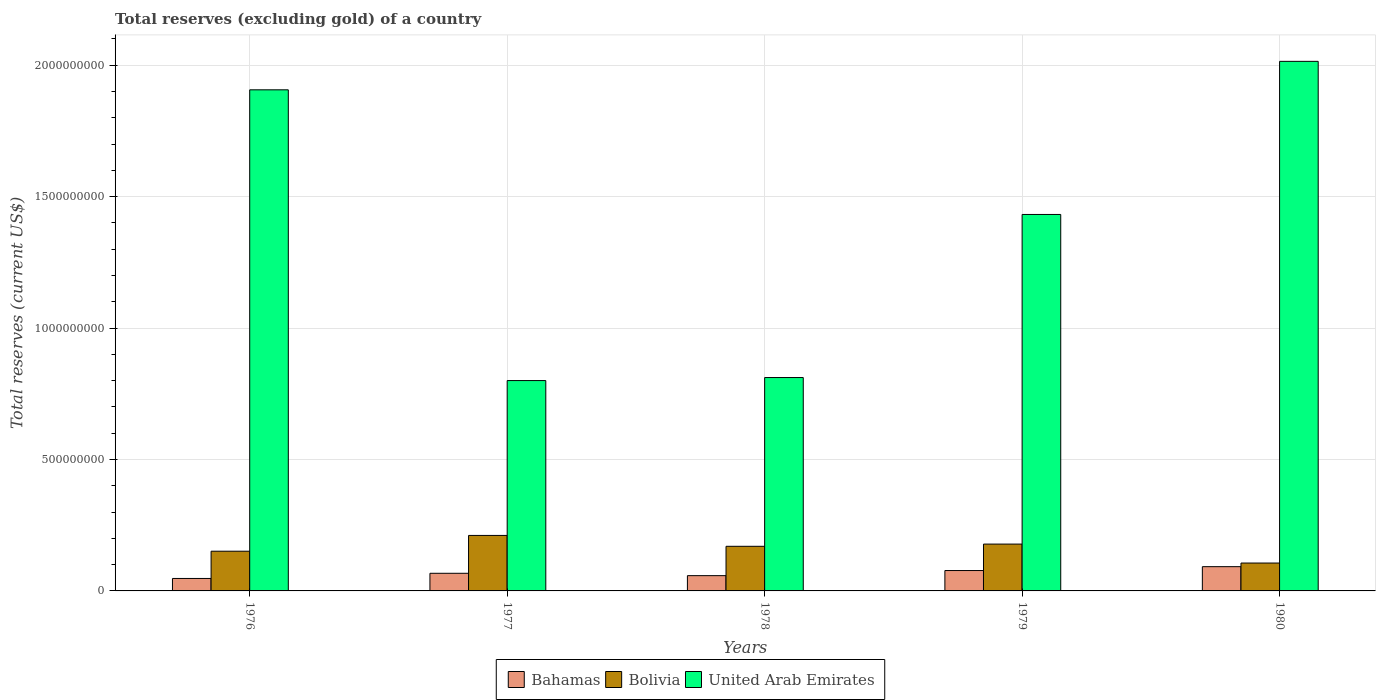How many different coloured bars are there?
Provide a succinct answer. 3. How many bars are there on the 4th tick from the left?
Your answer should be compact. 3. What is the label of the 4th group of bars from the left?
Offer a terse response. 1979. What is the total reserves (excluding gold) in United Arab Emirates in 1978?
Provide a succinct answer. 8.12e+08. Across all years, what is the maximum total reserves (excluding gold) in Bolivia?
Offer a very short reply. 2.11e+08. Across all years, what is the minimum total reserves (excluding gold) in United Arab Emirates?
Ensure brevity in your answer.  8.00e+08. In which year was the total reserves (excluding gold) in Bahamas minimum?
Provide a short and direct response. 1976. What is the total total reserves (excluding gold) in Bolivia in the graph?
Your response must be concise. 8.16e+08. What is the difference between the total reserves (excluding gold) in Bahamas in 1976 and that in 1977?
Give a very brief answer. -1.97e+07. What is the difference between the total reserves (excluding gold) in Bahamas in 1977 and the total reserves (excluding gold) in United Arab Emirates in 1980?
Your answer should be very brief. -1.95e+09. What is the average total reserves (excluding gold) in Bahamas per year?
Offer a terse response. 6.85e+07. In the year 1977, what is the difference between the total reserves (excluding gold) in United Arab Emirates and total reserves (excluding gold) in Bahamas?
Ensure brevity in your answer.  7.33e+08. In how many years, is the total reserves (excluding gold) in Bahamas greater than 400000000 US$?
Make the answer very short. 0. What is the ratio of the total reserves (excluding gold) in Bahamas in 1976 to that in 1978?
Give a very brief answer. 0.82. Is the total reserves (excluding gold) in Bolivia in 1976 less than that in 1980?
Give a very brief answer. No. Is the difference between the total reserves (excluding gold) in United Arab Emirates in 1976 and 1979 greater than the difference between the total reserves (excluding gold) in Bahamas in 1976 and 1979?
Your answer should be compact. Yes. What is the difference between the highest and the second highest total reserves (excluding gold) in United Arab Emirates?
Keep it short and to the point. 1.08e+08. What is the difference between the highest and the lowest total reserves (excluding gold) in Bahamas?
Your answer should be very brief. 4.49e+07. In how many years, is the total reserves (excluding gold) in Bahamas greater than the average total reserves (excluding gold) in Bahamas taken over all years?
Keep it short and to the point. 2. What does the 2nd bar from the left in 1977 represents?
Offer a very short reply. Bolivia. How many years are there in the graph?
Your answer should be compact. 5. What is the difference between two consecutive major ticks on the Y-axis?
Offer a very short reply. 5.00e+08. Are the values on the major ticks of Y-axis written in scientific E-notation?
Make the answer very short. No. Does the graph contain grids?
Provide a short and direct response. Yes. What is the title of the graph?
Provide a succinct answer. Total reserves (excluding gold) of a country. Does "Bahamas" appear as one of the legend labels in the graph?
Provide a succinct answer. Yes. What is the label or title of the X-axis?
Make the answer very short. Years. What is the label or title of the Y-axis?
Offer a terse response. Total reserves (current US$). What is the Total reserves (current US$) in Bahamas in 1976?
Ensure brevity in your answer.  4.74e+07. What is the Total reserves (current US$) in Bolivia in 1976?
Provide a succinct answer. 1.51e+08. What is the Total reserves (current US$) in United Arab Emirates in 1976?
Your answer should be compact. 1.91e+09. What is the Total reserves (current US$) of Bahamas in 1977?
Offer a terse response. 6.71e+07. What is the Total reserves (current US$) in Bolivia in 1977?
Your response must be concise. 2.11e+08. What is the Total reserves (current US$) in United Arab Emirates in 1977?
Your answer should be very brief. 8.00e+08. What is the Total reserves (current US$) of Bahamas in 1978?
Give a very brief answer. 5.81e+07. What is the Total reserves (current US$) in Bolivia in 1978?
Give a very brief answer. 1.70e+08. What is the Total reserves (current US$) of United Arab Emirates in 1978?
Provide a short and direct response. 8.12e+08. What is the Total reserves (current US$) in Bahamas in 1979?
Make the answer very short. 7.75e+07. What is the Total reserves (current US$) in Bolivia in 1979?
Your response must be concise. 1.78e+08. What is the Total reserves (current US$) of United Arab Emirates in 1979?
Your response must be concise. 1.43e+09. What is the Total reserves (current US$) in Bahamas in 1980?
Your answer should be very brief. 9.23e+07. What is the Total reserves (current US$) in Bolivia in 1980?
Your answer should be very brief. 1.06e+08. What is the Total reserves (current US$) of United Arab Emirates in 1980?
Your response must be concise. 2.01e+09. Across all years, what is the maximum Total reserves (current US$) in Bahamas?
Ensure brevity in your answer.  9.23e+07. Across all years, what is the maximum Total reserves (current US$) of Bolivia?
Your answer should be very brief. 2.11e+08. Across all years, what is the maximum Total reserves (current US$) in United Arab Emirates?
Offer a terse response. 2.01e+09. Across all years, what is the minimum Total reserves (current US$) of Bahamas?
Your answer should be compact. 4.74e+07. Across all years, what is the minimum Total reserves (current US$) in Bolivia?
Your response must be concise. 1.06e+08. Across all years, what is the minimum Total reserves (current US$) in United Arab Emirates?
Provide a succinct answer. 8.00e+08. What is the total Total reserves (current US$) in Bahamas in the graph?
Provide a succinct answer. 3.42e+08. What is the total Total reserves (current US$) in Bolivia in the graph?
Offer a terse response. 8.16e+08. What is the total Total reserves (current US$) of United Arab Emirates in the graph?
Your answer should be very brief. 6.97e+09. What is the difference between the Total reserves (current US$) in Bahamas in 1976 and that in 1977?
Your answer should be very brief. -1.97e+07. What is the difference between the Total reserves (current US$) of Bolivia in 1976 and that in 1977?
Your response must be concise. -6.00e+07. What is the difference between the Total reserves (current US$) in United Arab Emirates in 1976 and that in 1977?
Keep it short and to the point. 1.11e+09. What is the difference between the Total reserves (current US$) in Bahamas in 1976 and that in 1978?
Ensure brevity in your answer.  -1.07e+07. What is the difference between the Total reserves (current US$) in Bolivia in 1976 and that in 1978?
Give a very brief answer. -1.87e+07. What is the difference between the Total reserves (current US$) in United Arab Emirates in 1976 and that in 1978?
Make the answer very short. 1.09e+09. What is the difference between the Total reserves (current US$) in Bahamas in 1976 and that in 1979?
Provide a short and direct response. -3.01e+07. What is the difference between the Total reserves (current US$) of Bolivia in 1976 and that in 1979?
Your response must be concise. -2.71e+07. What is the difference between the Total reserves (current US$) of United Arab Emirates in 1976 and that in 1979?
Your answer should be compact. 4.74e+08. What is the difference between the Total reserves (current US$) of Bahamas in 1976 and that in 1980?
Make the answer very short. -4.49e+07. What is the difference between the Total reserves (current US$) of Bolivia in 1976 and that in 1980?
Provide a short and direct response. 4.50e+07. What is the difference between the Total reserves (current US$) in United Arab Emirates in 1976 and that in 1980?
Your answer should be very brief. -1.08e+08. What is the difference between the Total reserves (current US$) of Bahamas in 1977 and that in 1978?
Give a very brief answer. 8.97e+06. What is the difference between the Total reserves (current US$) of Bolivia in 1977 and that in 1978?
Ensure brevity in your answer.  4.13e+07. What is the difference between the Total reserves (current US$) in United Arab Emirates in 1977 and that in 1978?
Your answer should be compact. -1.16e+07. What is the difference between the Total reserves (current US$) in Bahamas in 1977 and that in 1979?
Offer a very short reply. -1.05e+07. What is the difference between the Total reserves (current US$) of Bolivia in 1977 and that in 1979?
Offer a very short reply. 3.29e+07. What is the difference between the Total reserves (current US$) of United Arab Emirates in 1977 and that in 1979?
Offer a terse response. -6.32e+08. What is the difference between the Total reserves (current US$) in Bahamas in 1977 and that in 1980?
Your answer should be compact. -2.52e+07. What is the difference between the Total reserves (current US$) of Bolivia in 1977 and that in 1980?
Ensure brevity in your answer.  1.05e+08. What is the difference between the Total reserves (current US$) in United Arab Emirates in 1977 and that in 1980?
Provide a succinct answer. -1.21e+09. What is the difference between the Total reserves (current US$) in Bahamas in 1978 and that in 1979?
Give a very brief answer. -1.94e+07. What is the difference between the Total reserves (current US$) in Bolivia in 1978 and that in 1979?
Make the answer very short. -8.43e+06. What is the difference between the Total reserves (current US$) in United Arab Emirates in 1978 and that in 1979?
Your response must be concise. -6.20e+08. What is the difference between the Total reserves (current US$) of Bahamas in 1978 and that in 1980?
Your answer should be compact. -3.42e+07. What is the difference between the Total reserves (current US$) in Bolivia in 1978 and that in 1980?
Offer a terse response. 6.37e+07. What is the difference between the Total reserves (current US$) of United Arab Emirates in 1978 and that in 1980?
Make the answer very short. -1.20e+09. What is the difference between the Total reserves (current US$) of Bahamas in 1979 and that in 1980?
Keep it short and to the point. -1.47e+07. What is the difference between the Total reserves (current US$) in Bolivia in 1979 and that in 1980?
Keep it short and to the point. 7.21e+07. What is the difference between the Total reserves (current US$) of United Arab Emirates in 1979 and that in 1980?
Make the answer very short. -5.82e+08. What is the difference between the Total reserves (current US$) of Bahamas in 1976 and the Total reserves (current US$) of Bolivia in 1977?
Offer a very short reply. -1.64e+08. What is the difference between the Total reserves (current US$) in Bahamas in 1976 and the Total reserves (current US$) in United Arab Emirates in 1977?
Provide a succinct answer. -7.53e+08. What is the difference between the Total reserves (current US$) in Bolivia in 1976 and the Total reserves (current US$) in United Arab Emirates in 1977?
Your answer should be compact. -6.49e+08. What is the difference between the Total reserves (current US$) of Bahamas in 1976 and the Total reserves (current US$) of Bolivia in 1978?
Ensure brevity in your answer.  -1.22e+08. What is the difference between the Total reserves (current US$) in Bahamas in 1976 and the Total reserves (current US$) in United Arab Emirates in 1978?
Provide a short and direct response. -7.64e+08. What is the difference between the Total reserves (current US$) in Bolivia in 1976 and the Total reserves (current US$) in United Arab Emirates in 1978?
Provide a succinct answer. -6.61e+08. What is the difference between the Total reserves (current US$) in Bahamas in 1976 and the Total reserves (current US$) in Bolivia in 1979?
Provide a succinct answer. -1.31e+08. What is the difference between the Total reserves (current US$) of Bahamas in 1976 and the Total reserves (current US$) of United Arab Emirates in 1979?
Ensure brevity in your answer.  -1.38e+09. What is the difference between the Total reserves (current US$) of Bolivia in 1976 and the Total reserves (current US$) of United Arab Emirates in 1979?
Keep it short and to the point. -1.28e+09. What is the difference between the Total reserves (current US$) in Bahamas in 1976 and the Total reserves (current US$) in Bolivia in 1980?
Your response must be concise. -5.87e+07. What is the difference between the Total reserves (current US$) of Bahamas in 1976 and the Total reserves (current US$) of United Arab Emirates in 1980?
Ensure brevity in your answer.  -1.97e+09. What is the difference between the Total reserves (current US$) of Bolivia in 1976 and the Total reserves (current US$) of United Arab Emirates in 1980?
Your response must be concise. -1.86e+09. What is the difference between the Total reserves (current US$) in Bahamas in 1977 and the Total reserves (current US$) in Bolivia in 1978?
Give a very brief answer. -1.03e+08. What is the difference between the Total reserves (current US$) of Bahamas in 1977 and the Total reserves (current US$) of United Arab Emirates in 1978?
Provide a succinct answer. -7.45e+08. What is the difference between the Total reserves (current US$) in Bolivia in 1977 and the Total reserves (current US$) in United Arab Emirates in 1978?
Your answer should be very brief. -6.01e+08. What is the difference between the Total reserves (current US$) in Bahamas in 1977 and the Total reserves (current US$) in Bolivia in 1979?
Offer a very short reply. -1.11e+08. What is the difference between the Total reserves (current US$) in Bahamas in 1977 and the Total reserves (current US$) in United Arab Emirates in 1979?
Give a very brief answer. -1.37e+09. What is the difference between the Total reserves (current US$) in Bolivia in 1977 and the Total reserves (current US$) in United Arab Emirates in 1979?
Give a very brief answer. -1.22e+09. What is the difference between the Total reserves (current US$) of Bahamas in 1977 and the Total reserves (current US$) of Bolivia in 1980?
Provide a succinct answer. -3.90e+07. What is the difference between the Total reserves (current US$) in Bahamas in 1977 and the Total reserves (current US$) in United Arab Emirates in 1980?
Offer a terse response. -1.95e+09. What is the difference between the Total reserves (current US$) in Bolivia in 1977 and the Total reserves (current US$) in United Arab Emirates in 1980?
Keep it short and to the point. -1.80e+09. What is the difference between the Total reserves (current US$) of Bahamas in 1978 and the Total reserves (current US$) of Bolivia in 1979?
Your response must be concise. -1.20e+08. What is the difference between the Total reserves (current US$) of Bahamas in 1978 and the Total reserves (current US$) of United Arab Emirates in 1979?
Your response must be concise. -1.37e+09. What is the difference between the Total reserves (current US$) in Bolivia in 1978 and the Total reserves (current US$) in United Arab Emirates in 1979?
Ensure brevity in your answer.  -1.26e+09. What is the difference between the Total reserves (current US$) in Bahamas in 1978 and the Total reserves (current US$) in Bolivia in 1980?
Your answer should be compact. -4.80e+07. What is the difference between the Total reserves (current US$) of Bahamas in 1978 and the Total reserves (current US$) of United Arab Emirates in 1980?
Ensure brevity in your answer.  -1.96e+09. What is the difference between the Total reserves (current US$) of Bolivia in 1978 and the Total reserves (current US$) of United Arab Emirates in 1980?
Make the answer very short. -1.84e+09. What is the difference between the Total reserves (current US$) of Bahamas in 1979 and the Total reserves (current US$) of Bolivia in 1980?
Make the answer very short. -2.86e+07. What is the difference between the Total reserves (current US$) of Bahamas in 1979 and the Total reserves (current US$) of United Arab Emirates in 1980?
Make the answer very short. -1.94e+09. What is the difference between the Total reserves (current US$) of Bolivia in 1979 and the Total reserves (current US$) of United Arab Emirates in 1980?
Give a very brief answer. -1.84e+09. What is the average Total reserves (current US$) in Bahamas per year?
Offer a terse response. 6.85e+07. What is the average Total reserves (current US$) of Bolivia per year?
Offer a very short reply. 1.63e+08. What is the average Total reserves (current US$) of United Arab Emirates per year?
Your answer should be compact. 1.39e+09. In the year 1976, what is the difference between the Total reserves (current US$) in Bahamas and Total reserves (current US$) in Bolivia?
Ensure brevity in your answer.  -1.04e+08. In the year 1976, what is the difference between the Total reserves (current US$) in Bahamas and Total reserves (current US$) in United Arab Emirates?
Provide a short and direct response. -1.86e+09. In the year 1976, what is the difference between the Total reserves (current US$) in Bolivia and Total reserves (current US$) in United Arab Emirates?
Offer a terse response. -1.76e+09. In the year 1977, what is the difference between the Total reserves (current US$) in Bahamas and Total reserves (current US$) in Bolivia?
Your answer should be very brief. -1.44e+08. In the year 1977, what is the difference between the Total reserves (current US$) in Bahamas and Total reserves (current US$) in United Arab Emirates?
Provide a succinct answer. -7.33e+08. In the year 1977, what is the difference between the Total reserves (current US$) in Bolivia and Total reserves (current US$) in United Arab Emirates?
Keep it short and to the point. -5.89e+08. In the year 1978, what is the difference between the Total reserves (current US$) in Bahamas and Total reserves (current US$) in Bolivia?
Ensure brevity in your answer.  -1.12e+08. In the year 1978, what is the difference between the Total reserves (current US$) in Bahamas and Total reserves (current US$) in United Arab Emirates?
Offer a very short reply. -7.54e+08. In the year 1978, what is the difference between the Total reserves (current US$) of Bolivia and Total reserves (current US$) of United Arab Emirates?
Your response must be concise. -6.42e+08. In the year 1979, what is the difference between the Total reserves (current US$) of Bahamas and Total reserves (current US$) of Bolivia?
Provide a succinct answer. -1.01e+08. In the year 1979, what is the difference between the Total reserves (current US$) of Bahamas and Total reserves (current US$) of United Arab Emirates?
Your answer should be compact. -1.35e+09. In the year 1979, what is the difference between the Total reserves (current US$) of Bolivia and Total reserves (current US$) of United Arab Emirates?
Offer a terse response. -1.25e+09. In the year 1980, what is the difference between the Total reserves (current US$) in Bahamas and Total reserves (current US$) in Bolivia?
Offer a very short reply. -1.38e+07. In the year 1980, what is the difference between the Total reserves (current US$) in Bahamas and Total reserves (current US$) in United Arab Emirates?
Offer a terse response. -1.92e+09. In the year 1980, what is the difference between the Total reserves (current US$) in Bolivia and Total reserves (current US$) in United Arab Emirates?
Your response must be concise. -1.91e+09. What is the ratio of the Total reserves (current US$) in Bahamas in 1976 to that in 1977?
Provide a short and direct response. 0.71. What is the ratio of the Total reserves (current US$) of Bolivia in 1976 to that in 1977?
Provide a succinct answer. 0.72. What is the ratio of the Total reserves (current US$) of United Arab Emirates in 1976 to that in 1977?
Keep it short and to the point. 2.38. What is the ratio of the Total reserves (current US$) of Bahamas in 1976 to that in 1978?
Offer a terse response. 0.82. What is the ratio of the Total reserves (current US$) in Bolivia in 1976 to that in 1978?
Your answer should be very brief. 0.89. What is the ratio of the Total reserves (current US$) of United Arab Emirates in 1976 to that in 1978?
Give a very brief answer. 2.35. What is the ratio of the Total reserves (current US$) of Bahamas in 1976 to that in 1979?
Make the answer very short. 0.61. What is the ratio of the Total reserves (current US$) in Bolivia in 1976 to that in 1979?
Provide a short and direct response. 0.85. What is the ratio of the Total reserves (current US$) in United Arab Emirates in 1976 to that in 1979?
Give a very brief answer. 1.33. What is the ratio of the Total reserves (current US$) of Bahamas in 1976 to that in 1980?
Provide a short and direct response. 0.51. What is the ratio of the Total reserves (current US$) in Bolivia in 1976 to that in 1980?
Your response must be concise. 1.42. What is the ratio of the Total reserves (current US$) of United Arab Emirates in 1976 to that in 1980?
Make the answer very short. 0.95. What is the ratio of the Total reserves (current US$) of Bahamas in 1977 to that in 1978?
Offer a very short reply. 1.15. What is the ratio of the Total reserves (current US$) of Bolivia in 1977 to that in 1978?
Your answer should be compact. 1.24. What is the ratio of the Total reserves (current US$) in United Arab Emirates in 1977 to that in 1978?
Provide a succinct answer. 0.99. What is the ratio of the Total reserves (current US$) in Bahamas in 1977 to that in 1979?
Your answer should be very brief. 0.87. What is the ratio of the Total reserves (current US$) in Bolivia in 1977 to that in 1979?
Your answer should be compact. 1.18. What is the ratio of the Total reserves (current US$) of United Arab Emirates in 1977 to that in 1979?
Provide a short and direct response. 0.56. What is the ratio of the Total reserves (current US$) of Bahamas in 1977 to that in 1980?
Your answer should be compact. 0.73. What is the ratio of the Total reserves (current US$) of Bolivia in 1977 to that in 1980?
Keep it short and to the point. 1.99. What is the ratio of the Total reserves (current US$) of United Arab Emirates in 1977 to that in 1980?
Give a very brief answer. 0.4. What is the ratio of the Total reserves (current US$) in Bahamas in 1978 to that in 1979?
Make the answer very short. 0.75. What is the ratio of the Total reserves (current US$) of Bolivia in 1978 to that in 1979?
Keep it short and to the point. 0.95. What is the ratio of the Total reserves (current US$) in United Arab Emirates in 1978 to that in 1979?
Your answer should be very brief. 0.57. What is the ratio of the Total reserves (current US$) in Bahamas in 1978 to that in 1980?
Offer a terse response. 0.63. What is the ratio of the Total reserves (current US$) in Bolivia in 1978 to that in 1980?
Offer a terse response. 1.6. What is the ratio of the Total reserves (current US$) of United Arab Emirates in 1978 to that in 1980?
Your answer should be compact. 0.4. What is the ratio of the Total reserves (current US$) in Bahamas in 1979 to that in 1980?
Your response must be concise. 0.84. What is the ratio of the Total reserves (current US$) in Bolivia in 1979 to that in 1980?
Provide a succinct answer. 1.68. What is the ratio of the Total reserves (current US$) of United Arab Emirates in 1979 to that in 1980?
Ensure brevity in your answer.  0.71. What is the difference between the highest and the second highest Total reserves (current US$) of Bahamas?
Keep it short and to the point. 1.47e+07. What is the difference between the highest and the second highest Total reserves (current US$) in Bolivia?
Offer a terse response. 3.29e+07. What is the difference between the highest and the second highest Total reserves (current US$) of United Arab Emirates?
Make the answer very short. 1.08e+08. What is the difference between the highest and the lowest Total reserves (current US$) of Bahamas?
Your response must be concise. 4.49e+07. What is the difference between the highest and the lowest Total reserves (current US$) of Bolivia?
Keep it short and to the point. 1.05e+08. What is the difference between the highest and the lowest Total reserves (current US$) in United Arab Emirates?
Ensure brevity in your answer.  1.21e+09. 